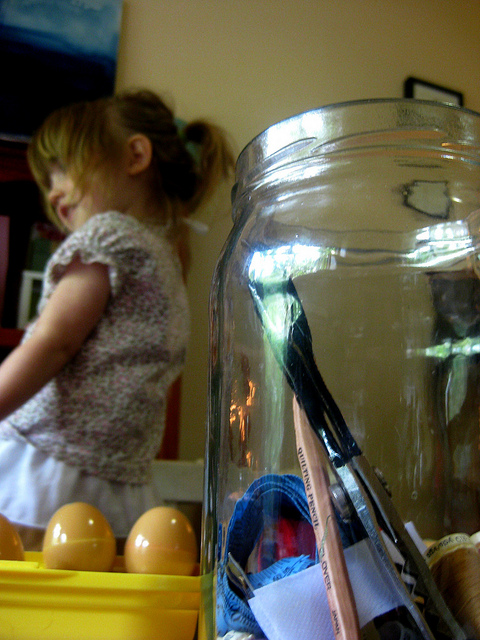How many elephants are facing toward the camera? There are no elephants in the image. The picture shows a young child in the background with some objects, including a clear jar containing various items and eggs in a yellow container, in the foreground. 